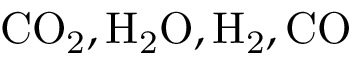<formula> <loc_0><loc_0><loc_500><loc_500>C O _ { 2 } , H _ { 2 } O , H _ { 2 } , C O</formula> 